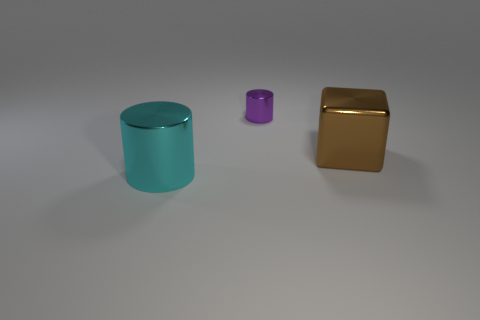If these objects were part of a set, what might their collective purpose be? They could represent different components of a modular storage set, where each object serves as a container, or they might be decorative pieces with an emphasis on geometric shapes and varying sizes. 